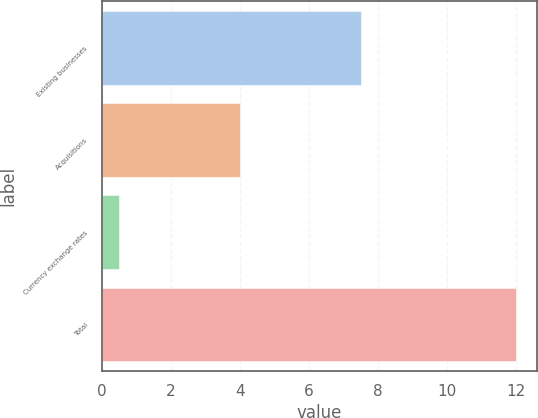Convert chart to OTSL. <chart><loc_0><loc_0><loc_500><loc_500><bar_chart><fcel>Existing businesses<fcel>Acquisitions<fcel>Currency exchange rates<fcel>Total<nl><fcel>7.5<fcel>4<fcel>0.5<fcel>12<nl></chart> 